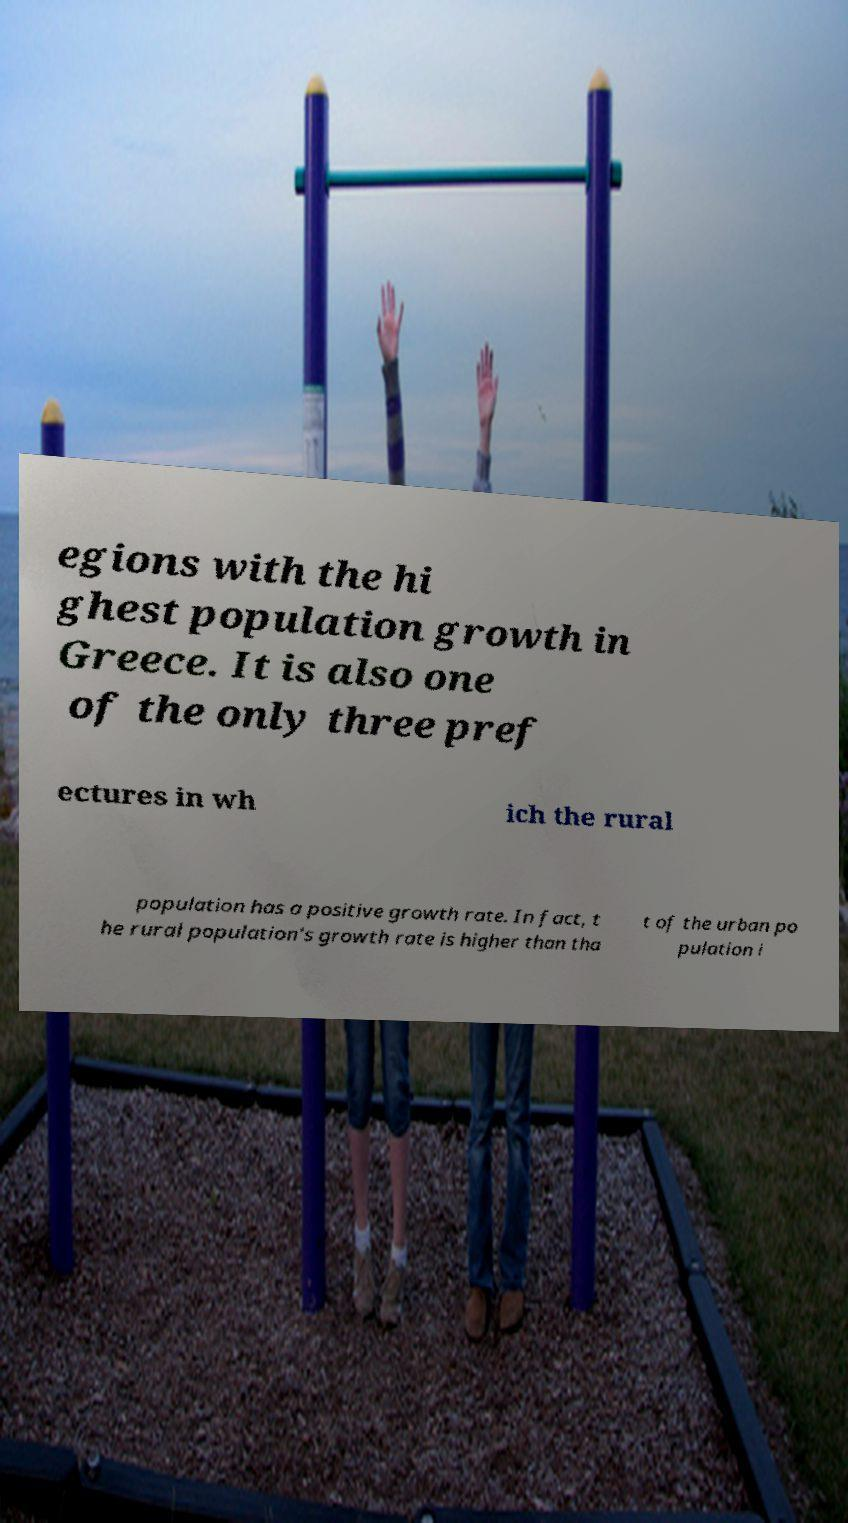Could you assist in decoding the text presented in this image and type it out clearly? egions with the hi ghest population growth in Greece. It is also one of the only three pref ectures in wh ich the rural population has a positive growth rate. In fact, t he rural population's growth rate is higher than tha t of the urban po pulation i 